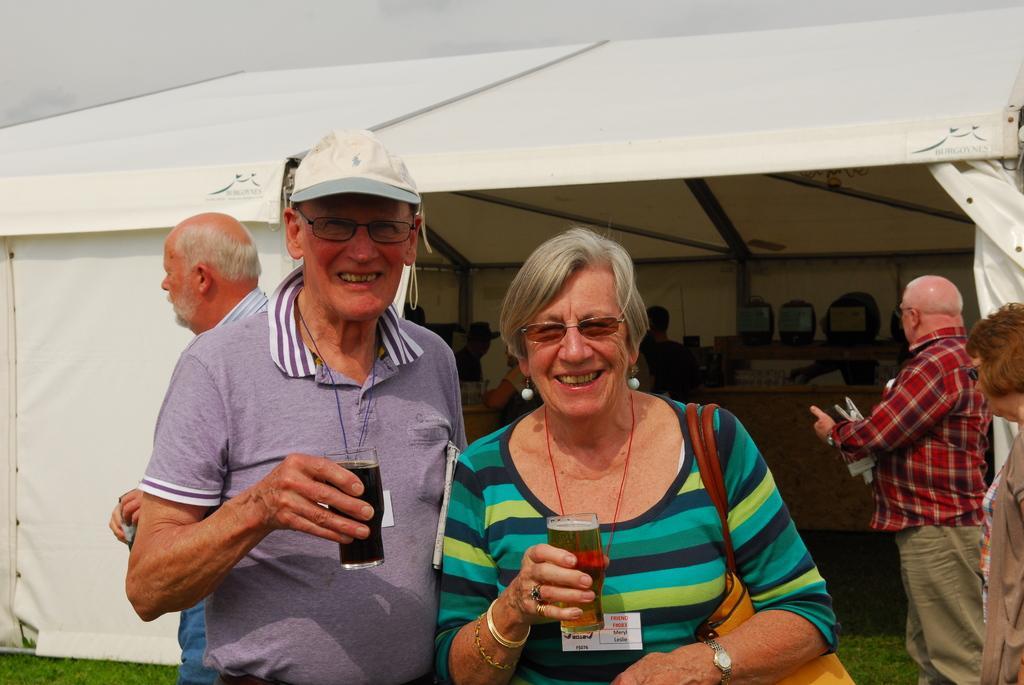Please provide a concise description of this image. In this image there is a man wearing a cap. He is holding a glass which is filled with drink. He is wearing spectacles. He is standing beside a woman. She is carrying bag and she is holding a glass which is filled with drink. Right side two persons are standing on the land. Left side there is a person. Behind him there is a tent. Few persons are under the tent. Few objects are kept on the shelf. Top of the image there is sky. 